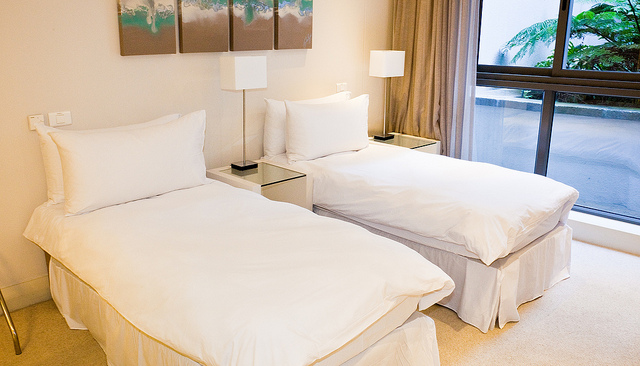What time of day does it seem to be outside? Given the natural light coming through the window and the open curtains, it appears to be daytime, although the exact time is not discernible. 